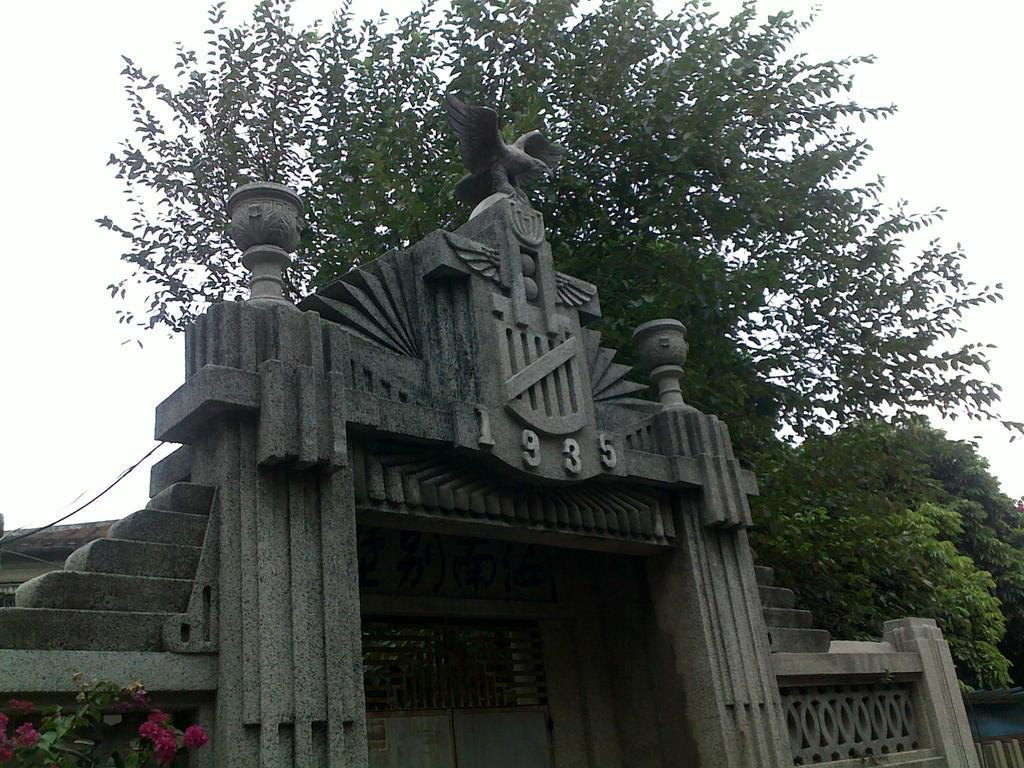Provide a one-sentence caption for the provided image. A gothic stone facade displays the number 1935 above the doorway. 